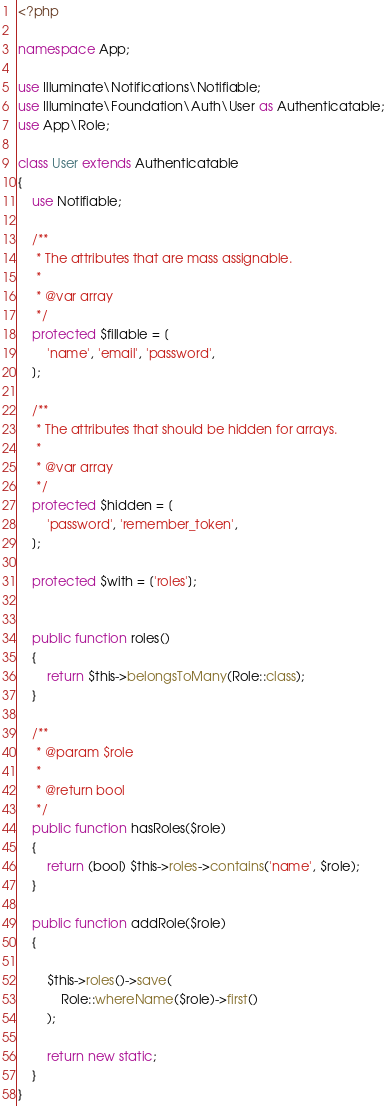Convert code to text. <code><loc_0><loc_0><loc_500><loc_500><_PHP_><?php

namespace App;

use Illuminate\Notifications\Notifiable;
use Illuminate\Foundation\Auth\User as Authenticatable;
use App\Role;

class User extends Authenticatable
{
    use Notifiable;

    /**
     * The attributes that are mass assignable.
     *
     * @var array
     */
    protected $fillable = [
        'name', 'email', 'password',
    ];

    /**
     * The attributes that should be hidden for arrays.
     *
     * @var array
     */
    protected $hidden = [
        'password', 'remember_token',
    ];

    protected $with = ['roles'];

    
    public function roles()
    {
        return $this->belongsToMany(Role::class);
    }

    /**
     * @param $role
     *
     * @return bool
     */
    public function hasRoles($role)
    {
        return (bool) $this->roles->contains('name', $role);
    }

    public function addRole($role)
    {
        
        $this->roles()->save(
            Role::whereName($role)->first()
        );
        
        return new static;
    }
}
</code> 